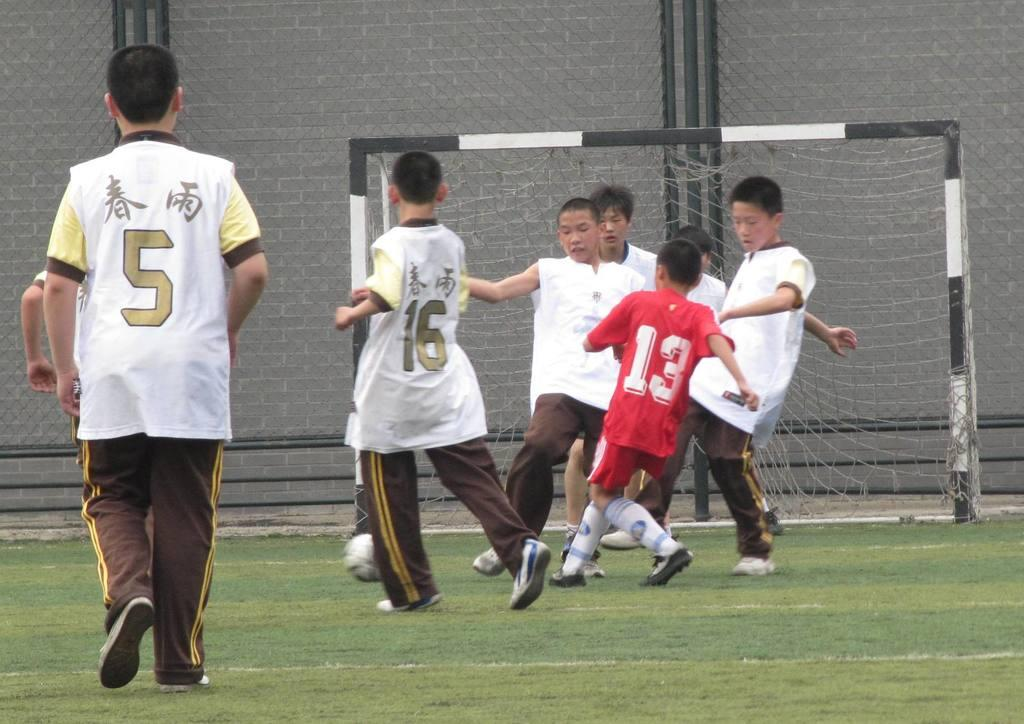<image>
Render a clear and concise summary of the photo. Player number 13 on the red team runs toward other players near the goal. 